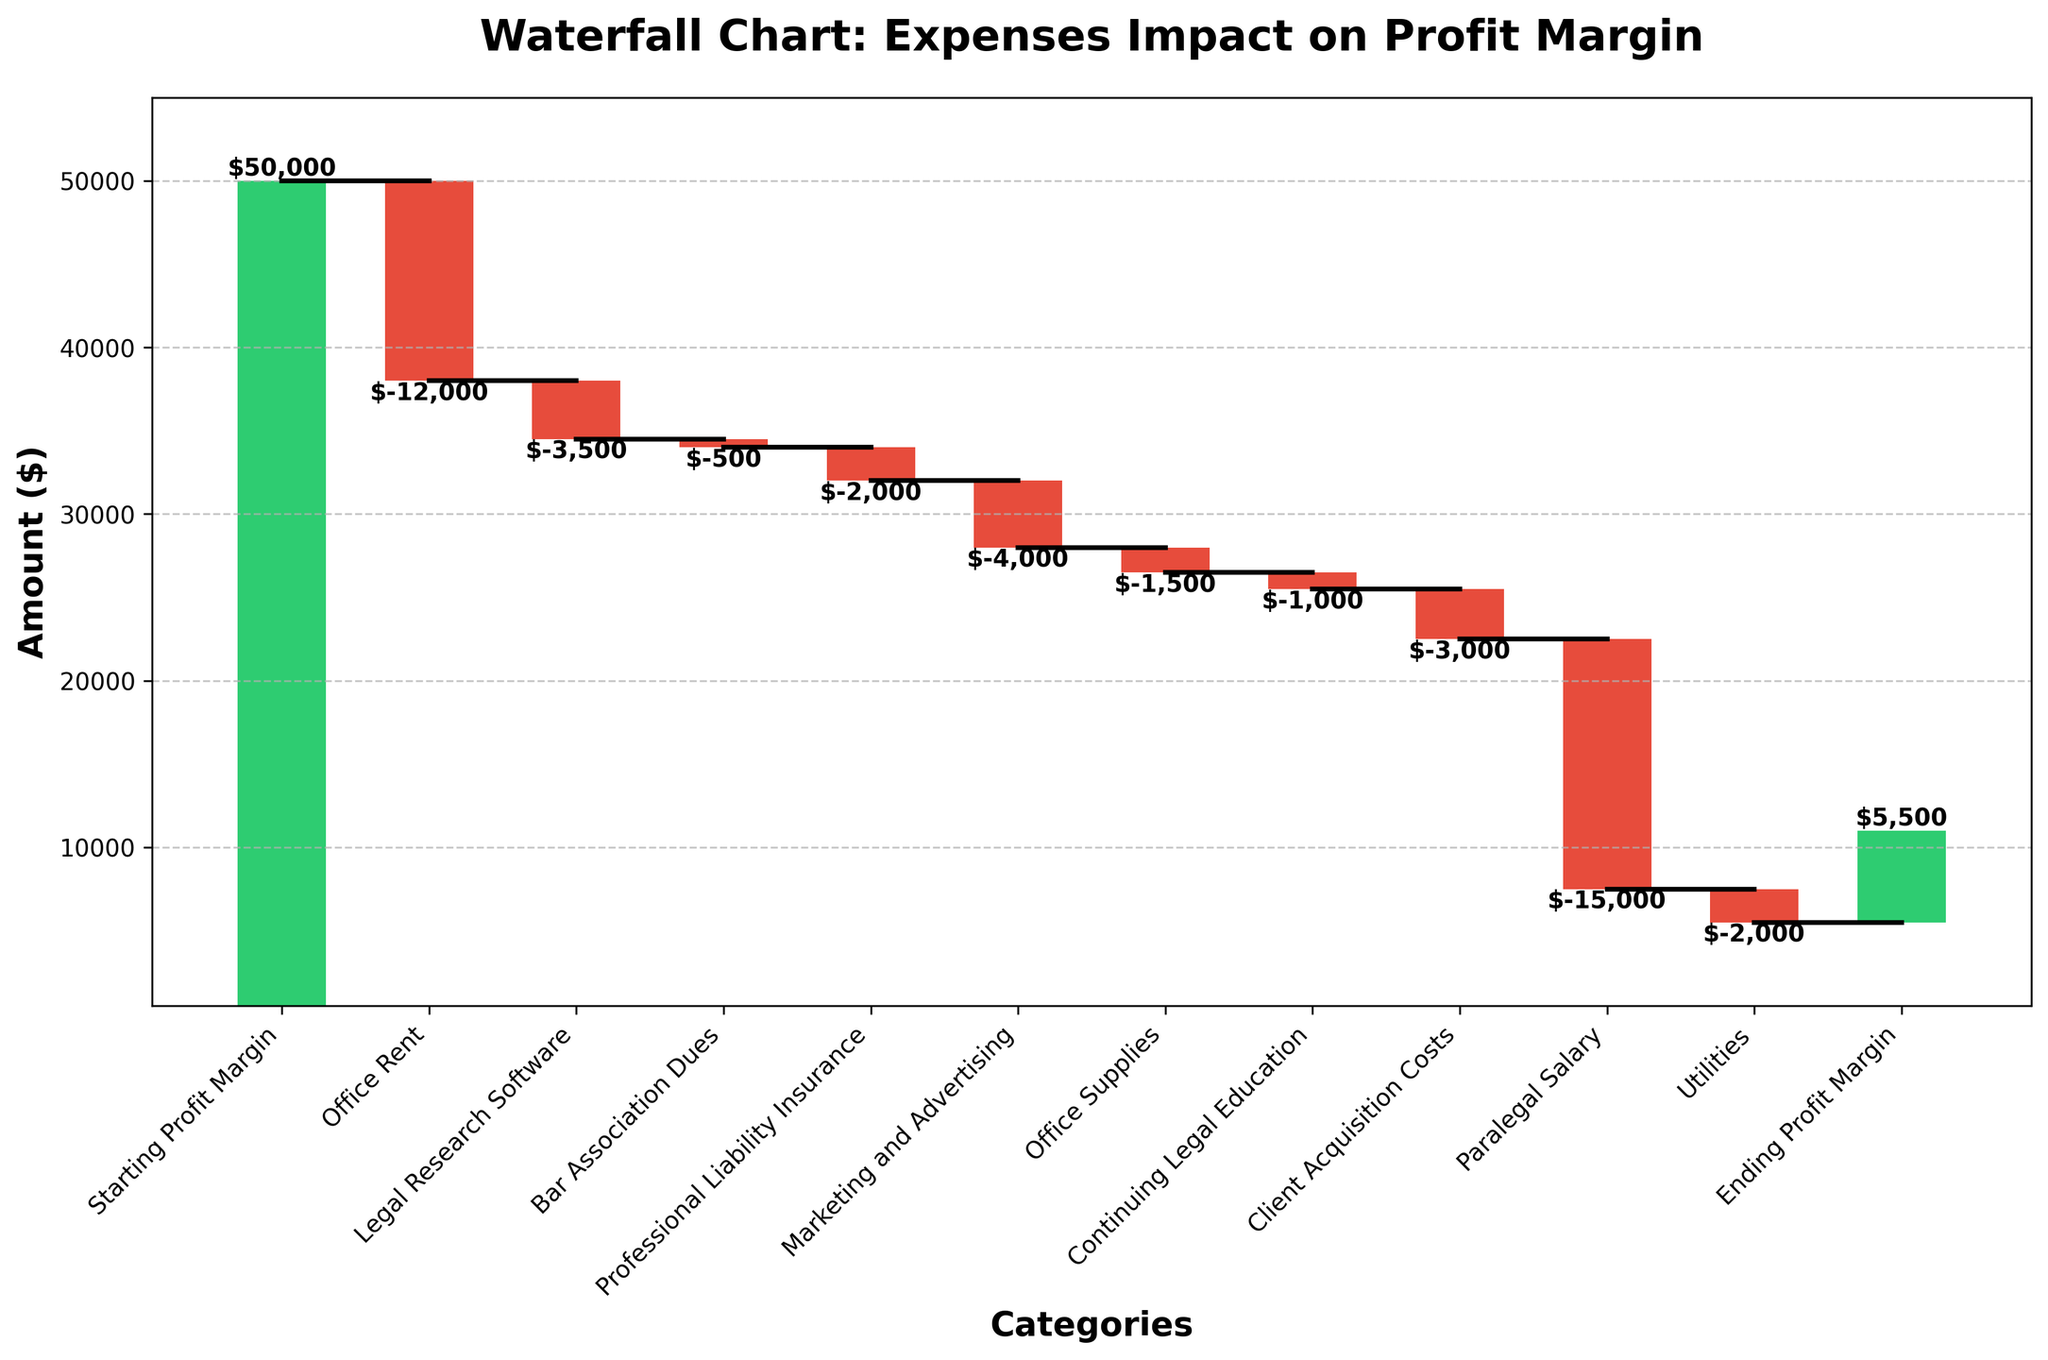What's the title of the chart? The title of the chart is displayed at the top.
Answer: Waterfall Chart: Expenses Impact on Profit Margin What is the final profit margin shown in the chart? The ending profit margin is labeled at the end of the waterfall chart.
Answer: $5,500 Which category has the largest negative impact on the profit margin? The length of the red bars represents categories with a negative impact. The "Paralegal Salary" category has the largest negative impact.
Answer: Paralegal Salary What total amount is spent on Office Rent and Utilities? Sum the negative amounts for Office Rent and Utilities. Office Rent is -$12,000 and Utilities is -$2,000. Adding them together gives -$14,000.
Answer: -$14,000 What is the difference between the Starting Profit Margin and the Ending Profit Margin? Subtract the Ending Profit Margin from the Starting Profit Margin. The Starting Profit Margin is $50,000 and the Ending Profit Margin is $5,500, so $50,000 - $5,500 = $44,500.
Answer: $44,500 How much does Legal Research Software cost compared to Marketing and Advertising? Compare the negative amounts for these two categories. Legal Research Software costs -$3,500 and Marketing and Advertising costs -$4,000.
Answer: Marketing and Advertising costs more by $500 What is the cumulative profit margin after deducting the Office Rent? The cumulative amount after the Office Rent impact can be found on the chart as the cumulative bar height after Office Rent. Starting Profit Margin ($50,000) - Office Rent ($12,000) = $38,000
Answer: $38,000 Which category contributes the smallest negative amount? The smallest red bar represents this category. The "Bar Association Dues" has the smallest negative amount.
Answer: Bar Association Dues What are the cumulative effects of Office Supplies and Continuing Legal Education on the profit margin? Sum the negative impacts of Office Supplies ($1,500) and Continuing Legal Education ($1,000). -$1,500 + -$1,000 = -$2,500.
Answer: -$2,500 Between Professional Liability Insurance and Client Acquisition Costs, which has a greater negative impact? Compare the lengths of the red bars for these two categories. Professional Liability Insurance is -$2,000 and Client Acquisition Costs is -$3,000.
Answer: Client Acquisition Costs 